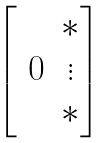Convert formula to latex. <formula><loc_0><loc_0><loc_500><loc_500>\begin{bmatrix} & * \\ \text { 0} & \vdots \\ & * \end{bmatrix}</formula> 